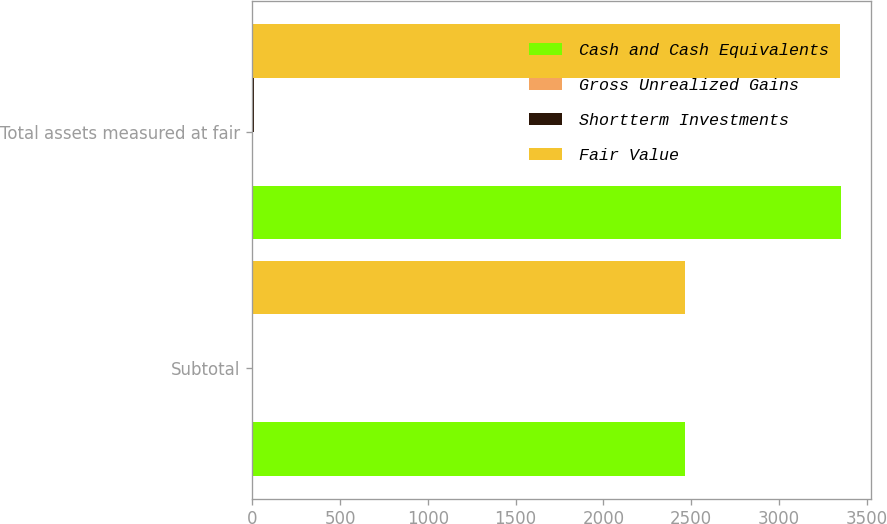Convert chart. <chart><loc_0><loc_0><loc_500><loc_500><stacked_bar_chart><ecel><fcel>Subtotal<fcel>Total assets measured at fair<nl><fcel>Cash and Cash Equivalents<fcel>2466.6<fcel>3353.4<nl><fcel>Gross Unrealized Gains<fcel>1.4<fcel>1.4<nl><fcel>Shortterm Investments<fcel>5.2<fcel>7<nl><fcel>Fair Value<fcel>2462.8<fcel>3347.8<nl></chart> 